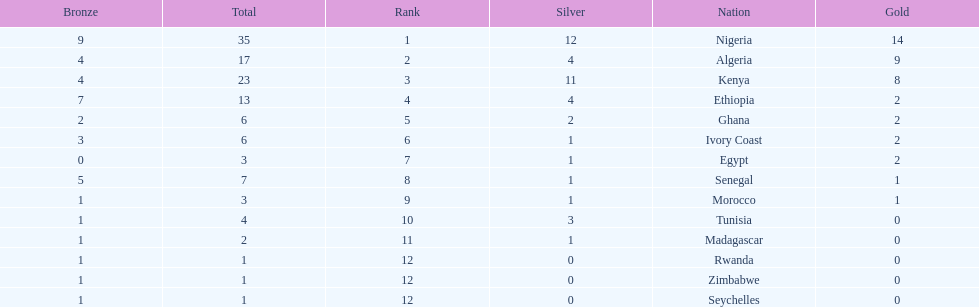Which nations have won only one medal? Rwanda, Zimbabwe, Seychelles. 